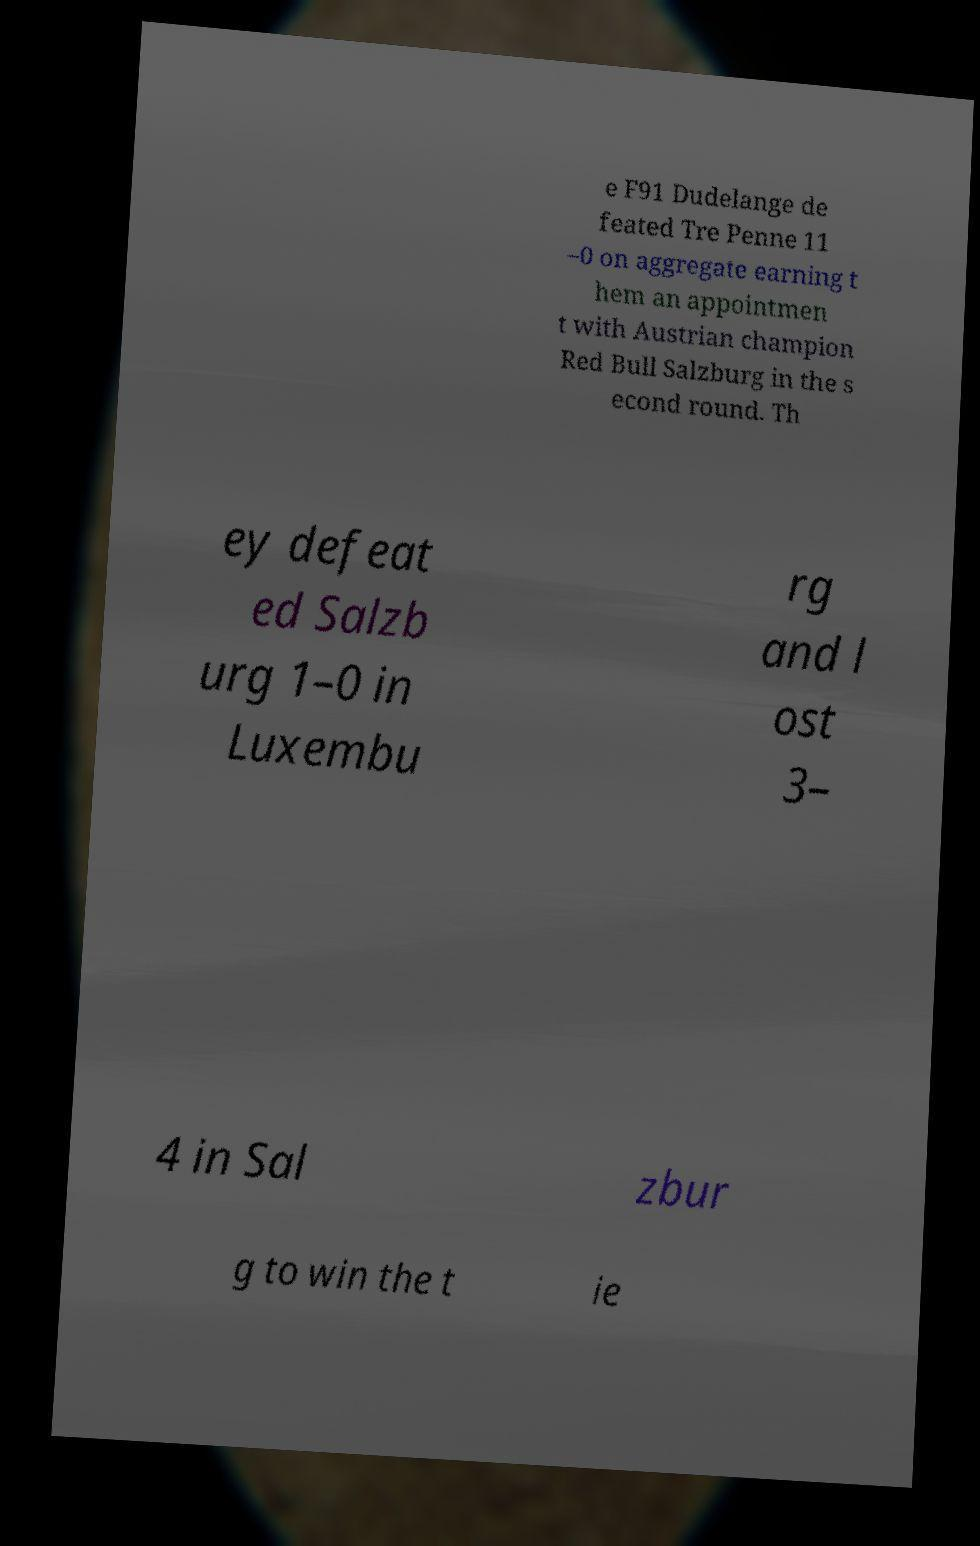Could you extract and type out the text from this image? e F91 Dudelange de feated Tre Penne 11 –0 on aggregate earning t hem an appointmen t with Austrian champion Red Bull Salzburg in the s econd round. Th ey defeat ed Salzb urg 1–0 in Luxembu rg and l ost 3– 4 in Sal zbur g to win the t ie 